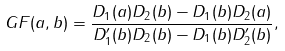<formula> <loc_0><loc_0><loc_500><loc_500>G F ( a , b ) = \frac { D _ { 1 } ( a ) D _ { 2 } ( b ) - D _ { 1 } ( b ) D _ { 2 } ( a ) } { D ^ { \prime } _ { 1 } ( b ) D _ { 2 } ( b ) - D _ { 1 } ( b ) D ^ { \prime } _ { 2 } ( b ) } ,</formula> 